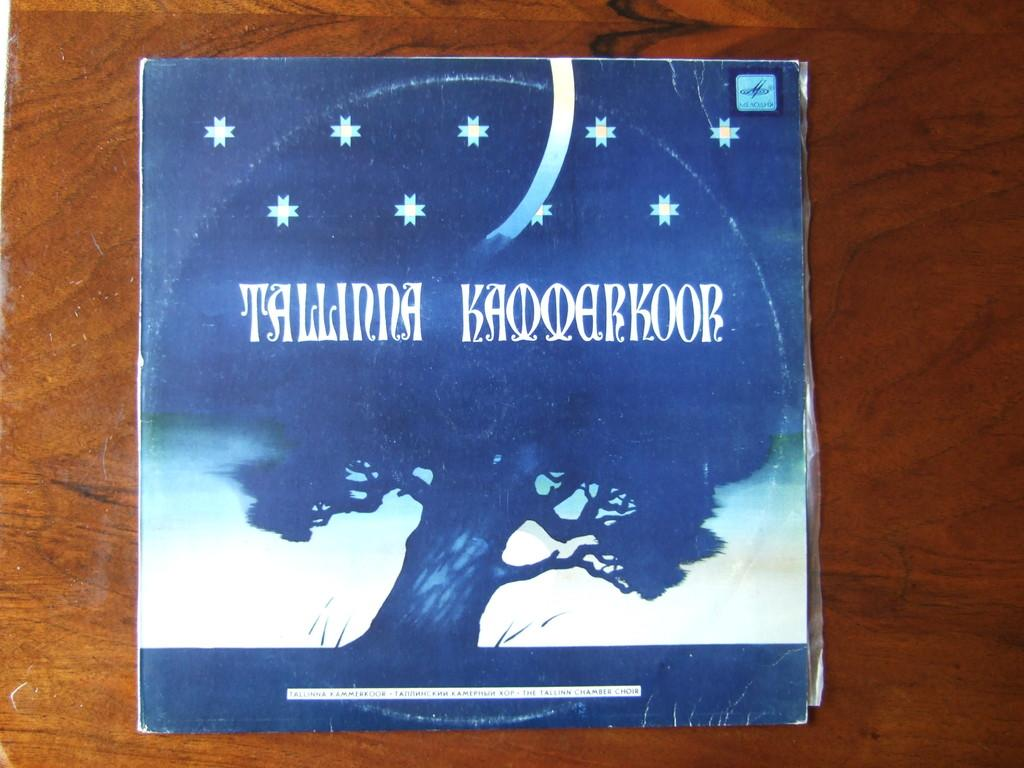Provide a one-sentence caption for the provided image. A  blue and white album cover with the word Talinna Kaooarkoor printed on the front. 